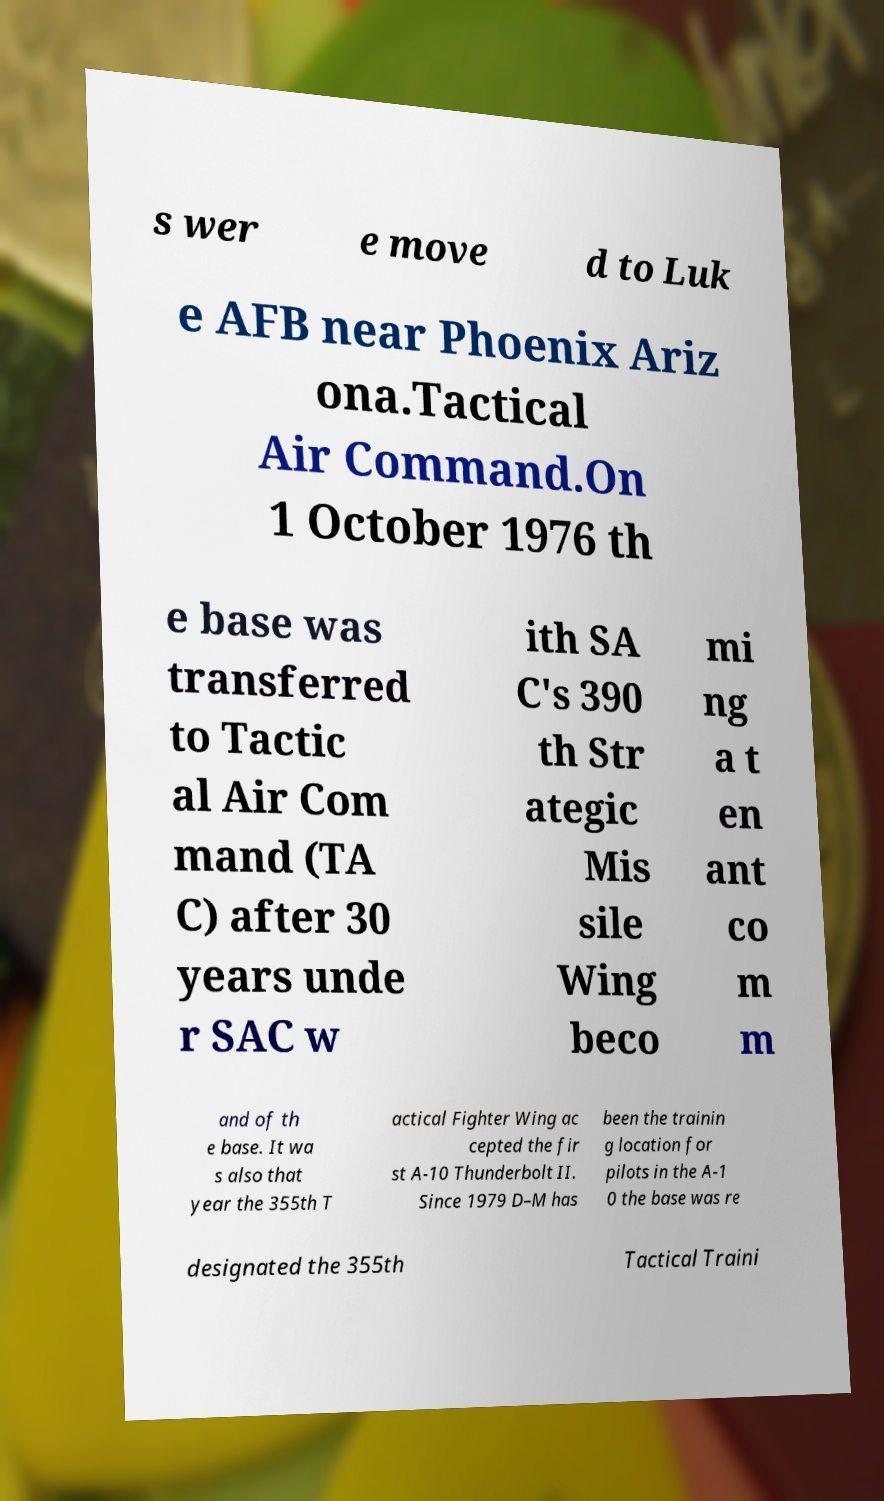Please read and relay the text visible in this image. What does it say? s wer e move d to Luk e AFB near Phoenix Ariz ona.Tactical Air Command.On 1 October 1976 th e base was transferred to Tactic al Air Com mand (TA C) after 30 years unde r SAC w ith SA C's 390 th Str ategic Mis sile Wing beco mi ng a t en ant co m m and of th e base. It wa s also that year the 355th T actical Fighter Wing ac cepted the fir st A-10 Thunderbolt II. Since 1979 D–M has been the trainin g location for pilots in the A-1 0 the base was re designated the 355th Tactical Traini 